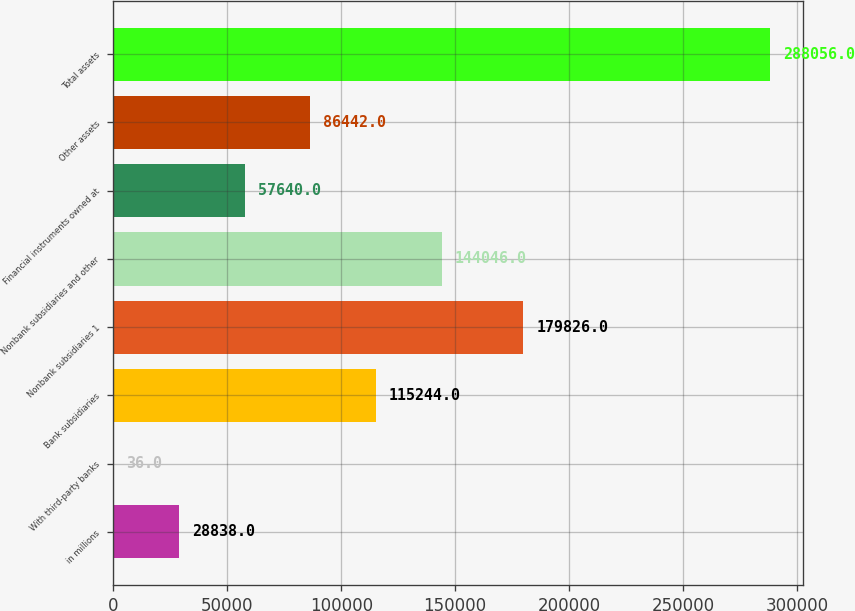Convert chart. <chart><loc_0><loc_0><loc_500><loc_500><bar_chart><fcel>in millions<fcel>With third-party banks<fcel>Bank subsidiaries<fcel>Nonbank subsidiaries 1<fcel>Nonbank subsidiaries and other<fcel>Financial instruments owned at<fcel>Other assets<fcel>Total assets<nl><fcel>28838<fcel>36<fcel>115244<fcel>179826<fcel>144046<fcel>57640<fcel>86442<fcel>288056<nl></chart> 